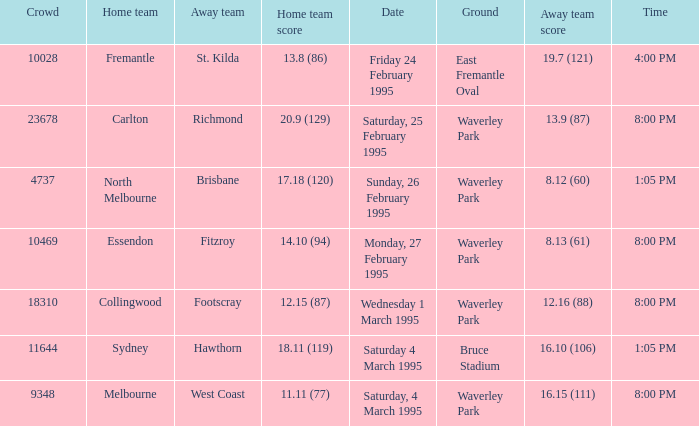Name the time for saturday 4 march 1995 1:05 PM. 